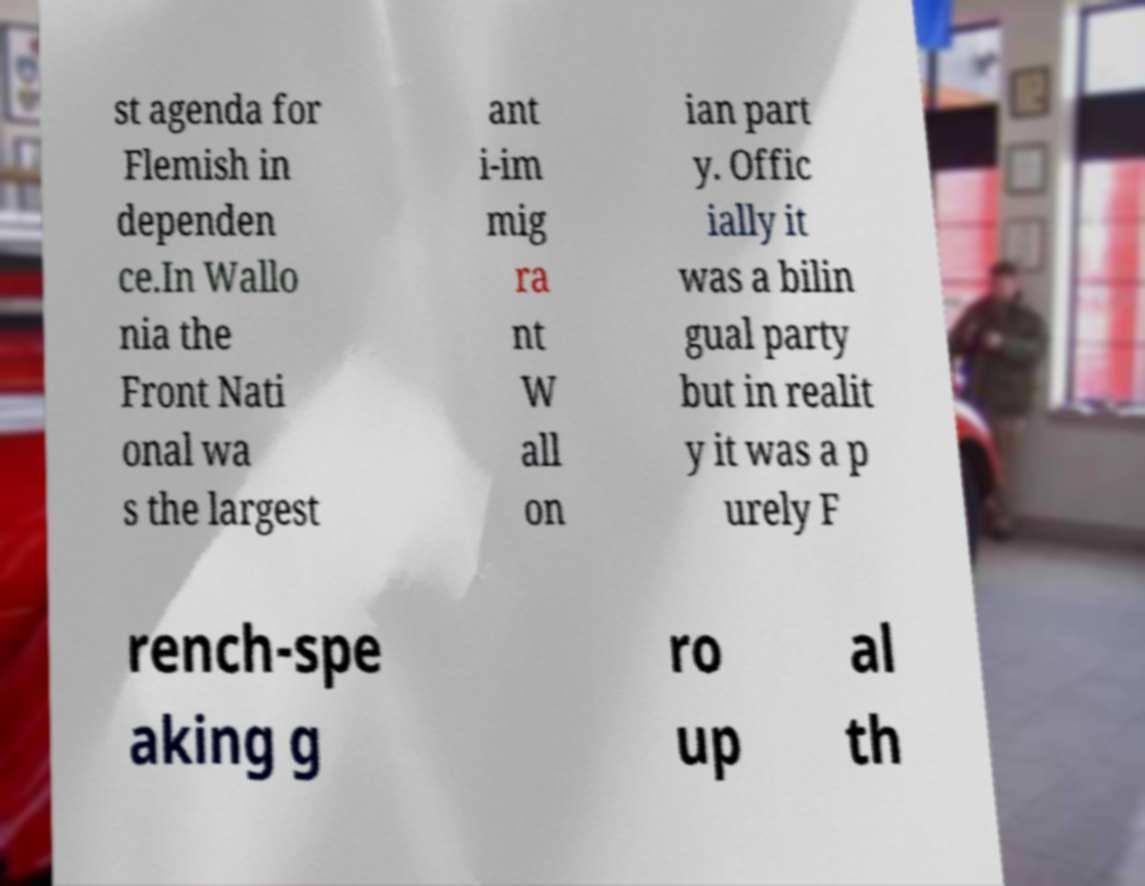What messages or text are displayed in this image? I need them in a readable, typed format. st agenda for Flemish in dependen ce.In Wallo nia the Front Nati onal wa s the largest ant i-im mig ra nt W all on ian part y. Offic ially it was a bilin gual party but in realit y it was a p urely F rench-spe aking g ro up al th 